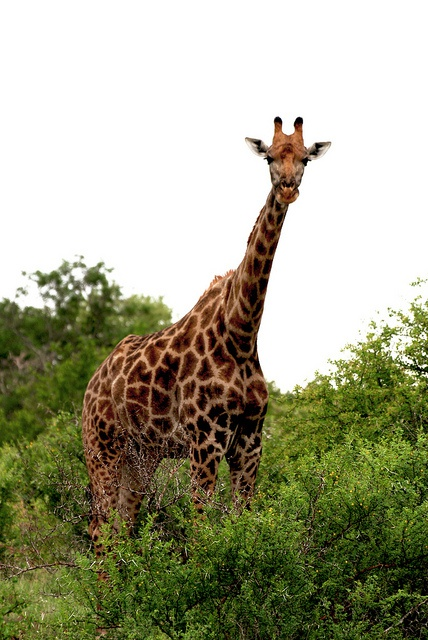Describe the objects in this image and their specific colors. I can see a giraffe in white, black, maroon, olive, and gray tones in this image. 